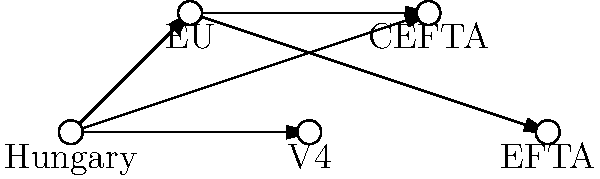In the given topology of trade agreements, which node represents the highest degree of connectivity for Hungary, and how does this impact Hungary's economic partnerships? To answer this question, we need to analyze the topology of the trade agreements shown in the diagram:

1. Identify the nodes:
   - Hungary
   - EU (European Union)
   - V4 (Visegrád Group)
   - CEFTA (Central European Free Trade Agreement)
   - EFTA (European Free Trade Association)

2. Count the connections for Hungary:
   - Hungary is directly connected to EU, V4, and CEFTA (3 connections)

3. Analyze the connections for other nodes:
   - EU is connected to Hungary, CEFTA, and EFTA (3 connections)
   - V4 is connected only to Hungary (1 connection)
   - CEFTA is connected to Hungary and EU (2 connections)
   - EFTA is connected only to EU (1 connection)

4. Determine the node with the highest connectivity:
   - Both Hungary and EU have the highest degree of connectivity with 3 connections each

5. Impact on Hungary's economic partnerships:
   - The EU represents the highest degree of connectivity for Hungary because:
     a. It provides direct access to the EU market
     b. It indirectly connects Hungary to EFTA
     c. It strengthens Hungary's position in CEFTA

6. Economic implications:
   - Increased trade opportunities within the EU single market
   - Potential for trade agreements with EFTA countries through EU negotiations
   - Enhanced regional cooperation through V4 and CEFTA
   - Diversified economic partnerships across different trade blocs

Therefore, the EU node represents the highest degree of connectivity for Hungary, providing the most significant impact on its economic partnerships through direct and indirect trade relations.
Answer: EU; provides direct market access, indirect EFTA connection, and strengthens CEFTA position 